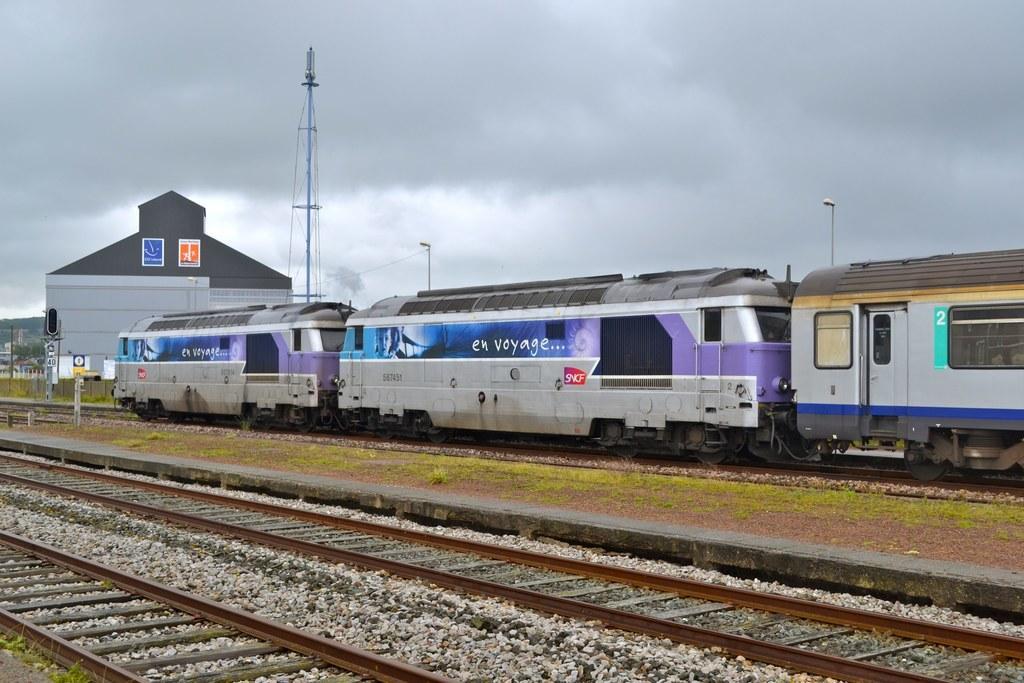Can you describe this image briefly? In this picture I can see the tracks, number of stones, a train and the grass in front. In the background, I can see a building, a tower, 2 poles and I can also see the cloudy sky. 